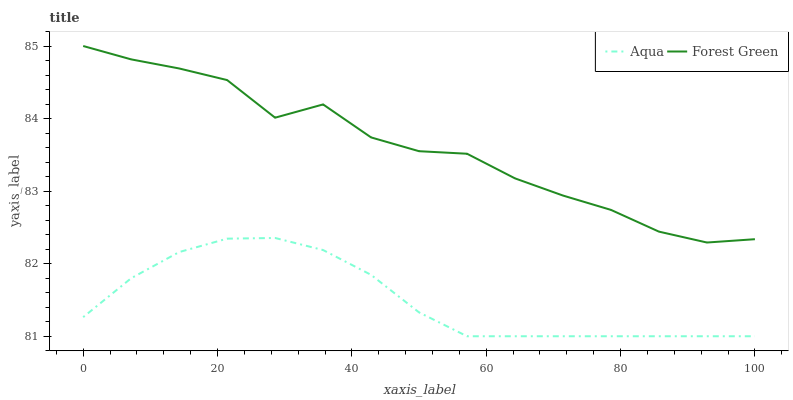Does Aqua have the minimum area under the curve?
Answer yes or no. Yes. Does Forest Green have the maximum area under the curve?
Answer yes or no. Yes. Does Aqua have the maximum area under the curve?
Answer yes or no. No. Is Aqua the smoothest?
Answer yes or no. Yes. Is Forest Green the roughest?
Answer yes or no. Yes. Is Aqua the roughest?
Answer yes or no. No. Does Aqua have the lowest value?
Answer yes or no. Yes. Does Forest Green have the highest value?
Answer yes or no. Yes. Does Aqua have the highest value?
Answer yes or no. No. Is Aqua less than Forest Green?
Answer yes or no. Yes. Is Forest Green greater than Aqua?
Answer yes or no. Yes. Does Aqua intersect Forest Green?
Answer yes or no. No. 